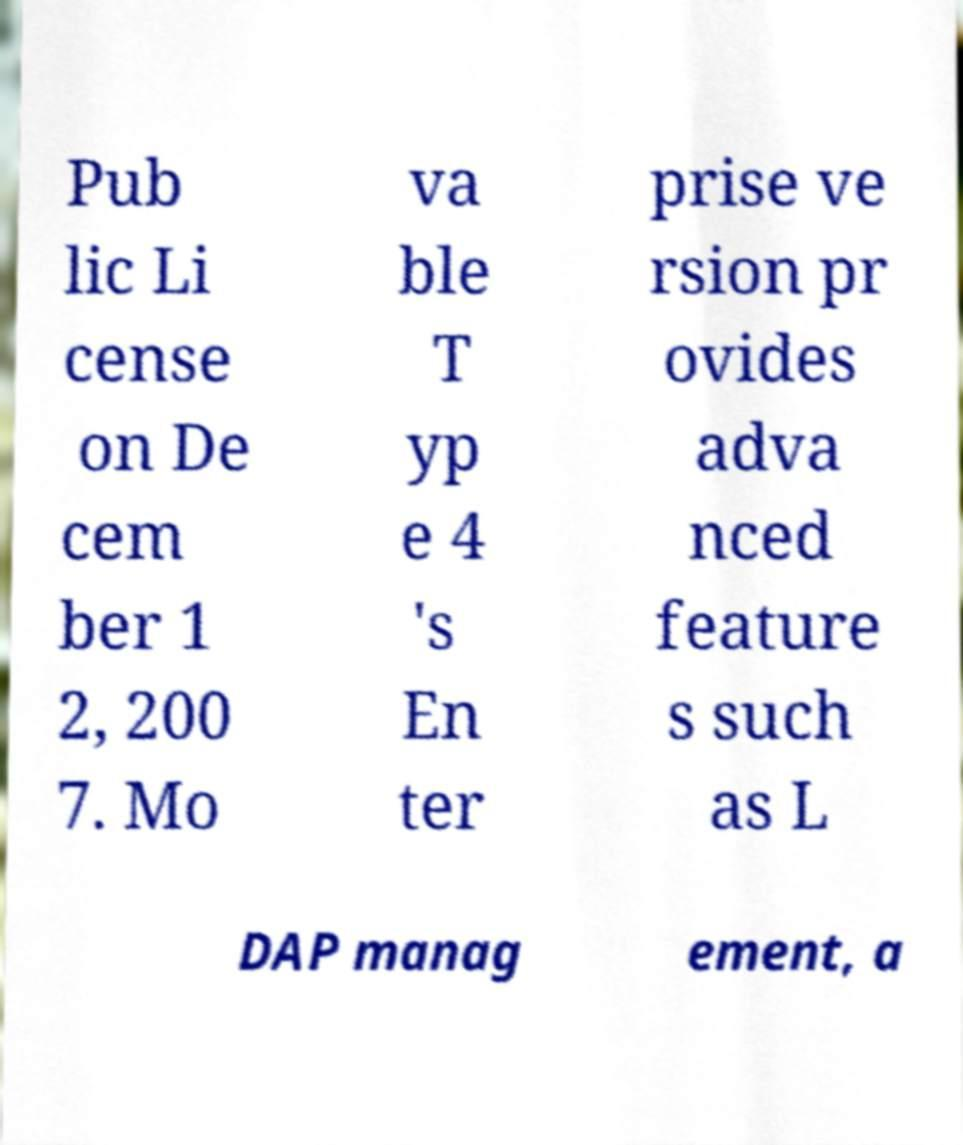For documentation purposes, I need the text within this image transcribed. Could you provide that? Pub lic Li cense on De cem ber 1 2, 200 7. Mo va ble T yp e 4 's En ter prise ve rsion pr ovides adva nced feature s such as L DAP manag ement, a 